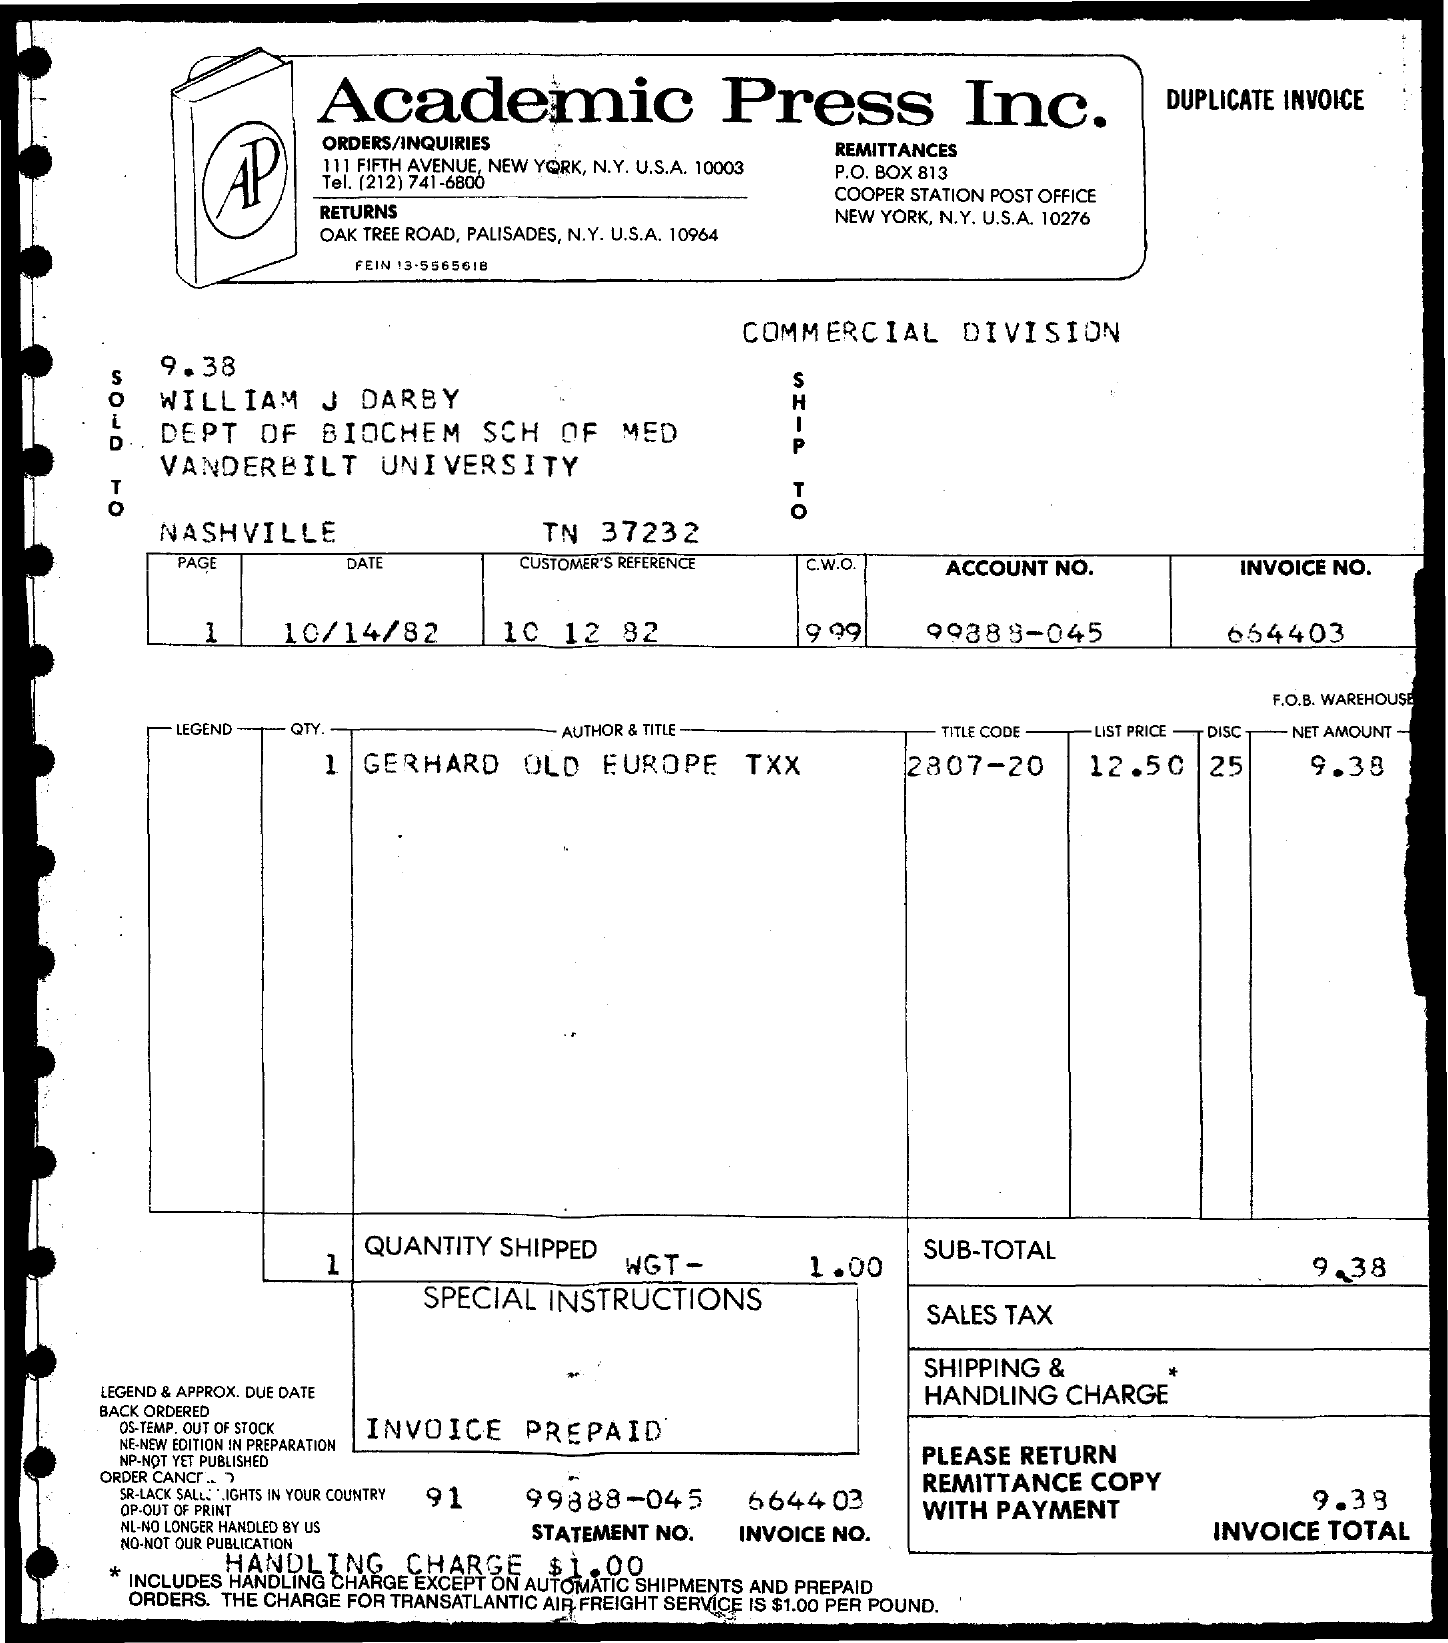What is the net amount?
 9.38 